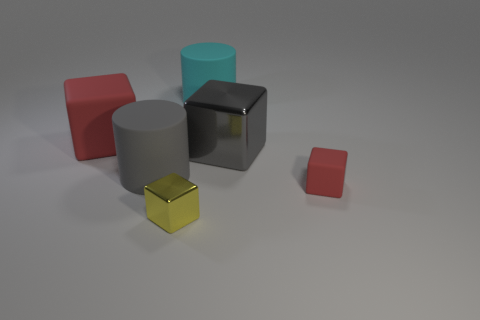What color is the large object left of the big gray object in front of the gray metallic thing?
Your answer should be very brief. Red. The large gray metallic object has what shape?
Provide a short and direct response. Cube. The object that is both in front of the large gray metal block and on the right side of the cyan thing has what shape?
Keep it short and to the point. Cube. There is another big thing that is the same material as the yellow object; what color is it?
Your answer should be compact. Gray. The large gray thing that is left of the large matte thing right of the block in front of the tiny red matte block is what shape?
Provide a short and direct response. Cylinder. What size is the yellow metallic object?
Your response must be concise. Small. There is a big red object that is the same material as the big gray cylinder; what shape is it?
Your answer should be very brief. Cube. Is the number of gray objects that are in front of the large gray rubber thing less than the number of big cyan cubes?
Give a very brief answer. No. What color is the large matte cylinder in front of the gray block?
Your answer should be compact. Gray. There is a cube that is the same color as the tiny rubber object; what material is it?
Your answer should be compact. Rubber. 